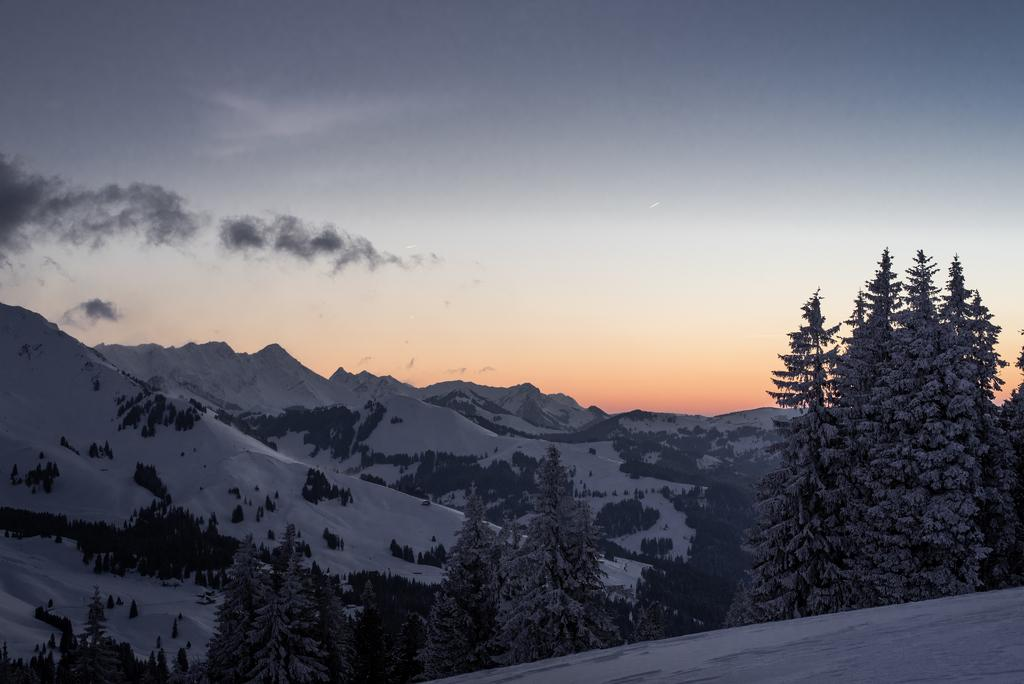What type of vegetation can be seen in the image? There are trees in the image. What is covering the trees in the image? The trees are covered with snow. What geographical features are visible in the image? There are mountains in the image. What is covering the mountains in the image? The mountains are covered with snow. What can be seen in the background of the image? The sky is visible in the background of the image. Can you see any fowl flying over the mountains in the image? There is no mention of fowl or any flying objects in the image; it only features trees, mountains, snow, and the sky. 